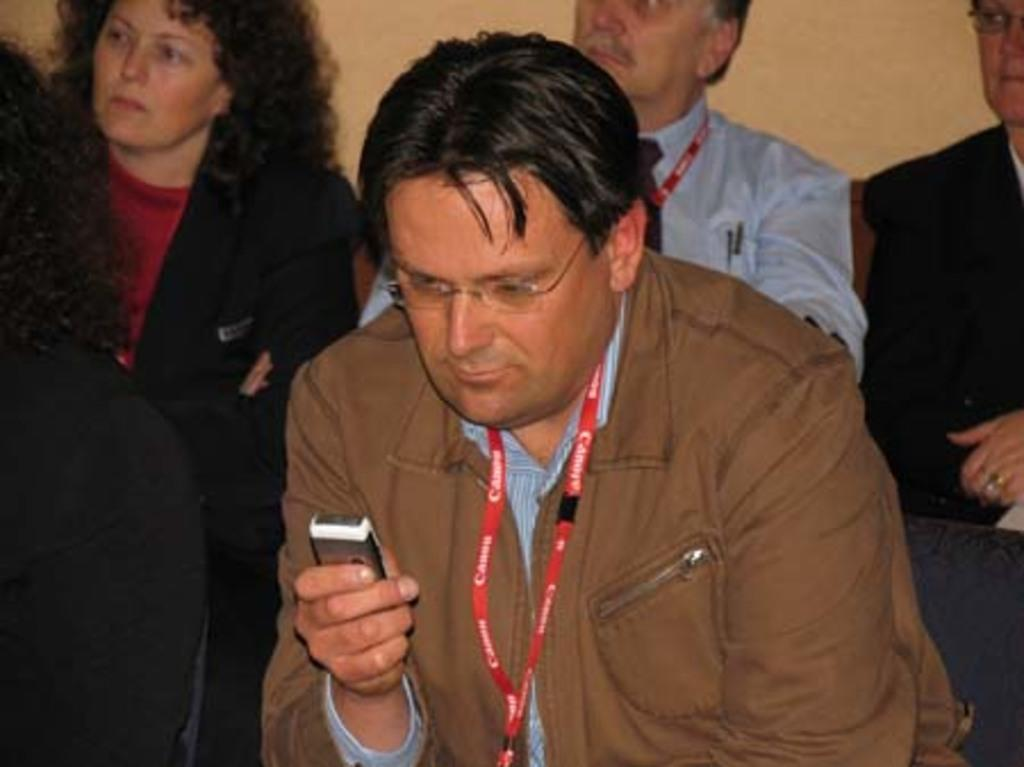What is the person in the foreground of the picture doing? The person is holding a mobile in the foreground of the picture. Where is the person sitting in the image? There is a person sitting in a chair on the left side of the image. Can you describe the people in the background of the image? There are people sitting in the background of the image. How many kittens are sitting on the person's lap in the image? There are no kittens present in the image. What type of bird can be seen flying in the background of the image? There is no bird visible in the image. 